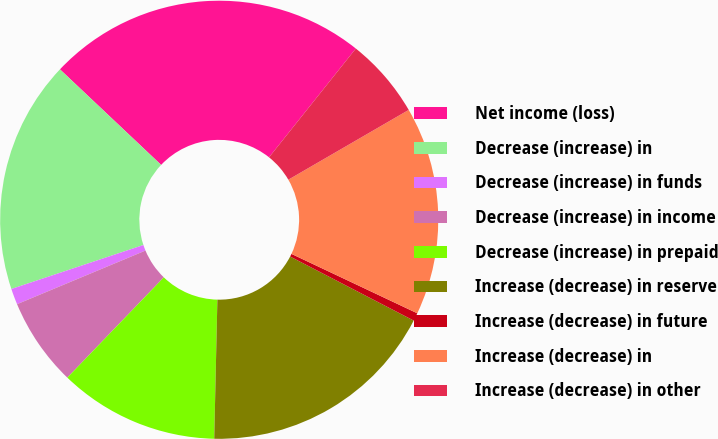<chart> <loc_0><loc_0><loc_500><loc_500><pie_chart><fcel>Net income (loss)<fcel>Decrease (increase) in<fcel>Decrease (increase) in funds<fcel>Decrease (increase) in income<fcel>Decrease (increase) in prepaid<fcel>Increase (decrease) in reserve<fcel>Increase (decrease) in future<fcel>Increase (decrease) in<fcel>Increase (decrease) in other<nl><fcel>23.67%<fcel>17.16%<fcel>1.18%<fcel>6.51%<fcel>11.83%<fcel>17.75%<fcel>0.59%<fcel>15.38%<fcel>5.92%<nl></chart> 